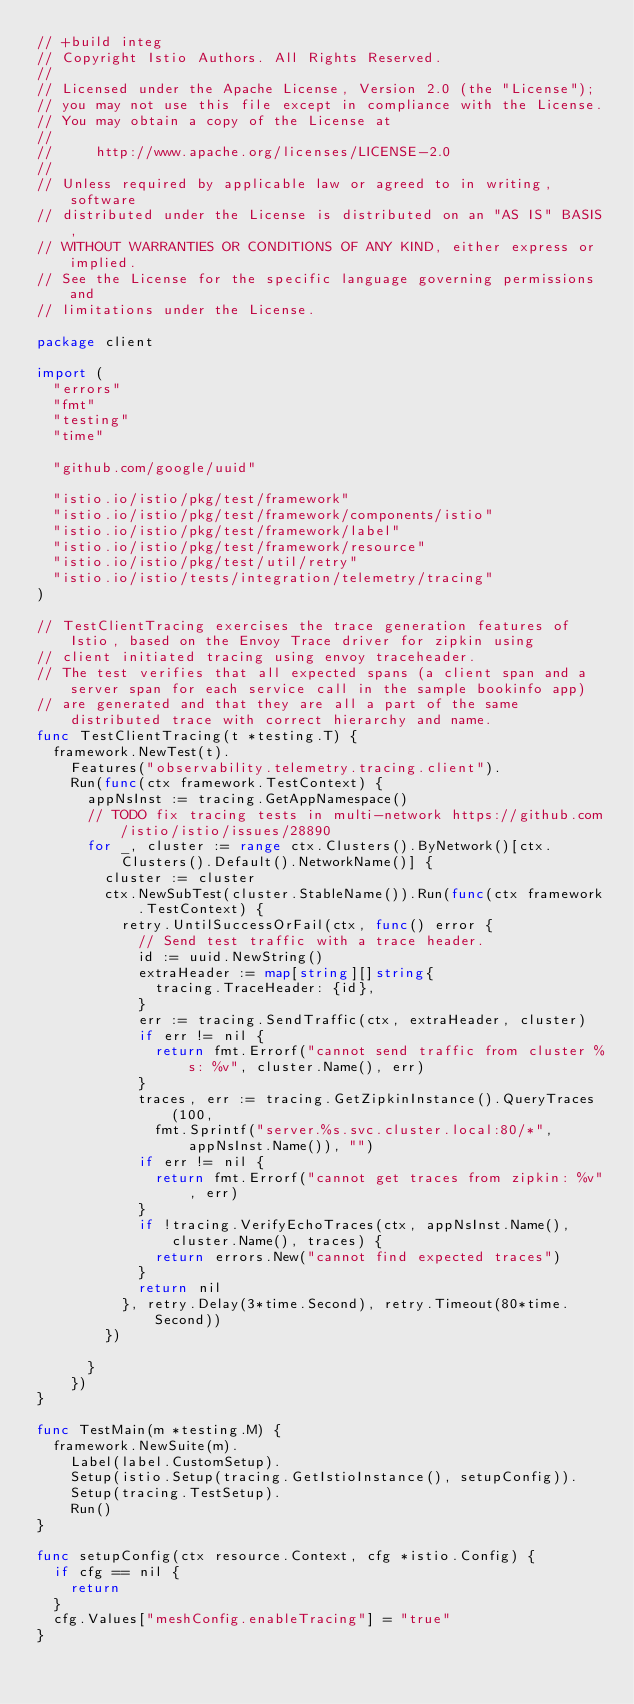<code> <loc_0><loc_0><loc_500><loc_500><_Go_>// +build integ
// Copyright Istio Authors. All Rights Reserved.
//
// Licensed under the Apache License, Version 2.0 (the "License");
// you may not use this file except in compliance with the License.
// You may obtain a copy of the License at
//
//     http://www.apache.org/licenses/LICENSE-2.0
//
// Unless required by applicable law or agreed to in writing, software
// distributed under the License is distributed on an "AS IS" BASIS,
// WITHOUT WARRANTIES OR CONDITIONS OF ANY KIND, either express or implied.
// See the License for the specific language governing permissions and
// limitations under the License.

package client

import (
	"errors"
	"fmt"
	"testing"
	"time"

	"github.com/google/uuid"

	"istio.io/istio/pkg/test/framework"
	"istio.io/istio/pkg/test/framework/components/istio"
	"istio.io/istio/pkg/test/framework/label"
	"istio.io/istio/pkg/test/framework/resource"
	"istio.io/istio/pkg/test/util/retry"
	"istio.io/istio/tests/integration/telemetry/tracing"
)

// TestClientTracing exercises the trace generation features of Istio, based on the Envoy Trace driver for zipkin using
// client initiated tracing using envoy traceheader.
// The test verifies that all expected spans (a client span and a server span for each service call in the sample bookinfo app)
// are generated and that they are all a part of the same distributed trace with correct hierarchy and name.
func TestClientTracing(t *testing.T) {
	framework.NewTest(t).
		Features("observability.telemetry.tracing.client").
		Run(func(ctx framework.TestContext) {
			appNsInst := tracing.GetAppNamespace()
			// TODO fix tracing tests in multi-network https://github.com/istio/istio/issues/28890
			for _, cluster := range ctx.Clusters().ByNetwork()[ctx.Clusters().Default().NetworkName()] {
				cluster := cluster
				ctx.NewSubTest(cluster.StableName()).Run(func(ctx framework.TestContext) {
					retry.UntilSuccessOrFail(ctx, func() error {
						// Send test traffic with a trace header.
						id := uuid.NewString()
						extraHeader := map[string][]string{
							tracing.TraceHeader: {id},
						}
						err := tracing.SendTraffic(ctx, extraHeader, cluster)
						if err != nil {
							return fmt.Errorf("cannot send traffic from cluster %s: %v", cluster.Name(), err)
						}
						traces, err := tracing.GetZipkinInstance().QueryTraces(100,
							fmt.Sprintf("server.%s.svc.cluster.local:80/*", appNsInst.Name()), "")
						if err != nil {
							return fmt.Errorf("cannot get traces from zipkin: %v", err)
						}
						if !tracing.VerifyEchoTraces(ctx, appNsInst.Name(), cluster.Name(), traces) {
							return errors.New("cannot find expected traces")
						}
						return nil
					}, retry.Delay(3*time.Second), retry.Timeout(80*time.Second))
				})

			}
		})
}

func TestMain(m *testing.M) {
	framework.NewSuite(m).
		Label(label.CustomSetup).
		Setup(istio.Setup(tracing.GetIstioInstance(), setupConfig)).
		Setup(tracing.TestSetup).
		Run()
}

func setupConfig(ctx resource.Context, cfg *istio.Config) {
	if cfg == nil {
		return
	}
	cfg.Values["meshConfig.enableTracing"] = "true"
}
</code> 